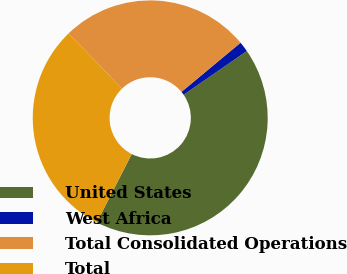Convert chart. <chart><loc_0><loc_0><loc_500><loc_500><pie_chart><fcel>United States<fcel>West Africa<fcel>Total Consolidated Operations<fcel>Total<nl><fcel>42.15%<fcel>1.41%<fcel>26.18%<fcel>30.26%<nl></chart> 